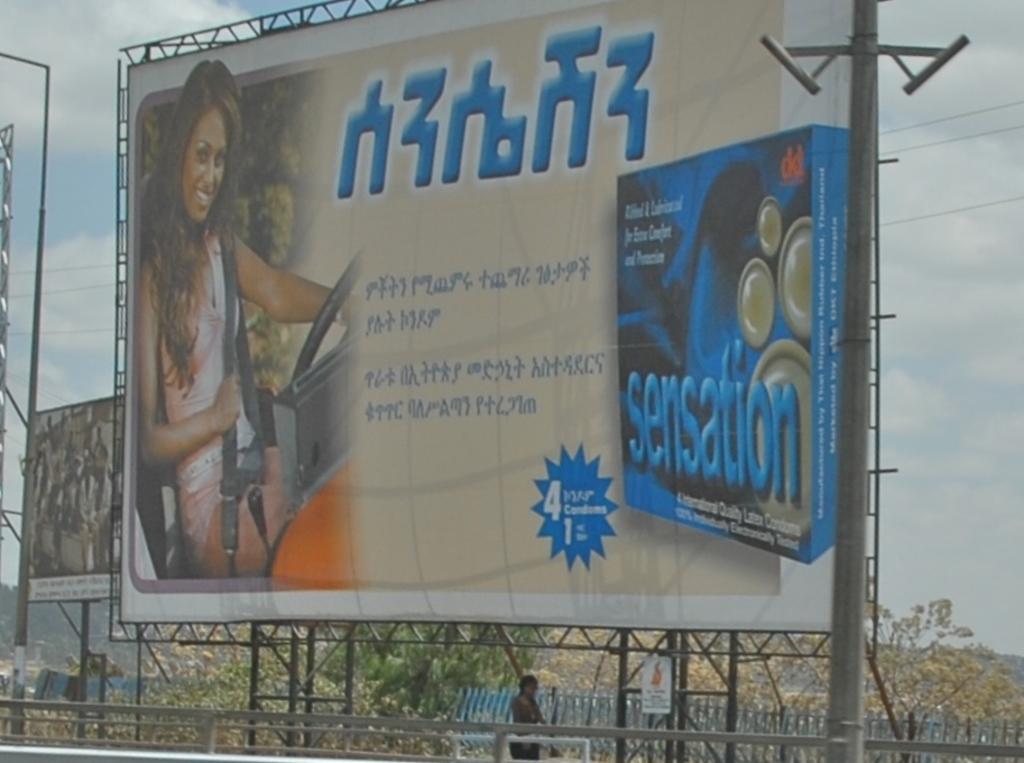What word is in blue, on the blue box?
Provide a succinct answer. Sensation. What number is on the ad?
Make the answer very short. 4. 